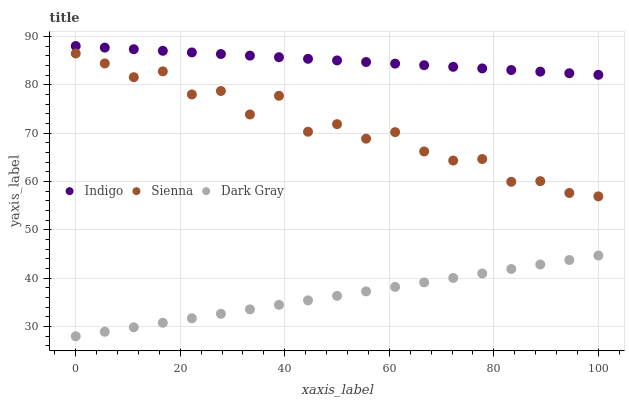Does Dark Gray have the minimum area under the curve?
Answer yes or no. Yes. Does Indigo have the maximum area under the curve?
Answer yes or no. Yes. Does Indigo have the minimum area under the curve?
Answer yes or no. No. Does Dark Gray have the maximum area under the curve?
Answer yes or no. No. Is Dark Gray the smoothest?
Answer yes or no. Yes. Is Sienna the roughest?
Answer yes or no. Yes. Is Indigo the smoothest?
Answer yes or no. No. Is Indigo the roughest?
Answer yes or no. No. Does Dark Gray have the lowest value?
Answer yes or no. Yes. Does Indigo have the lowest value?
Answer yes or no. No. Does Indigo have the highest value?
Answer yes or no. Yes. Does Dark Gray have the highest value?
Answer yes or no. No. Is Sienna less than Indigo?
Answer yes or no. Yes. Is Indigo greater than Sienna?
Answer yes or no. Yes. Does Sienna intersect Indigo?
Answer yes or no. No. 